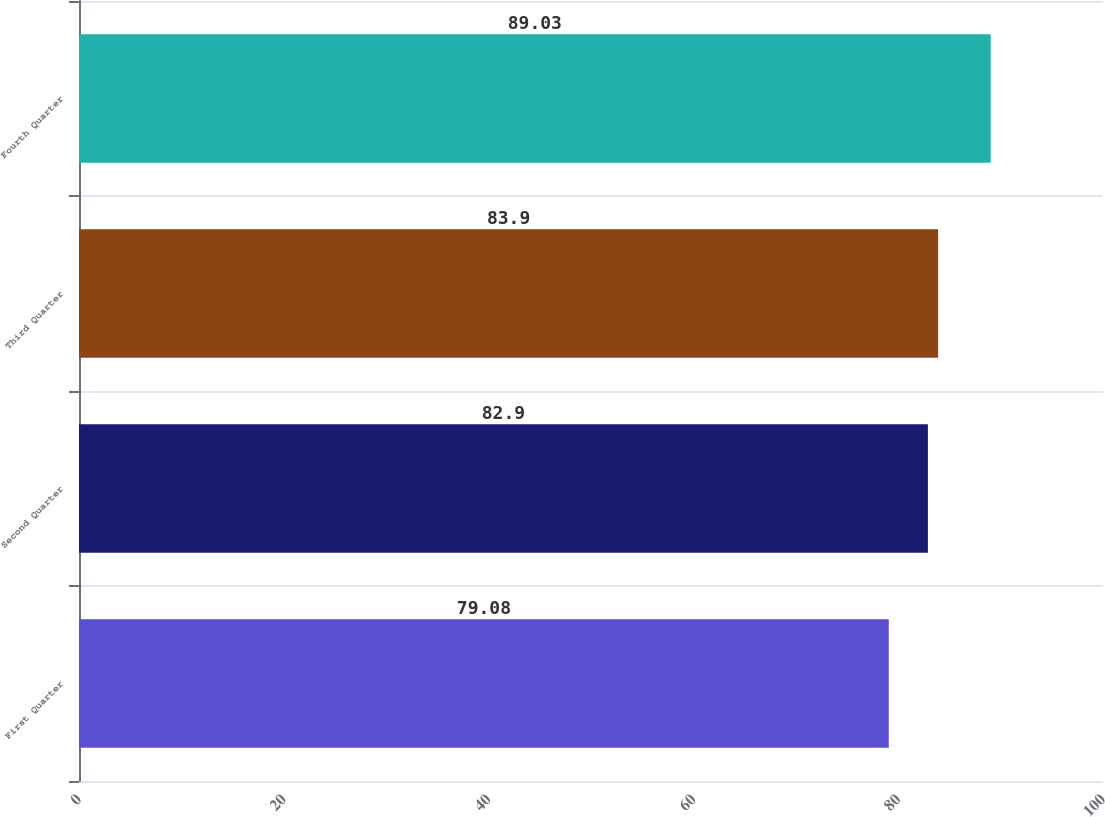Convert chart to OTSL. <chart><loc_0><loc_0><loc_500><loc_500><bar_chart><fcel>First Quarter<fcel>Second Quarter<fcel>Third Quarter<fcel>Fourth Quarter<nl><fcel>79.08<fcel>82.9<fcel>83.9<fcel>89.03<nl></chart> 